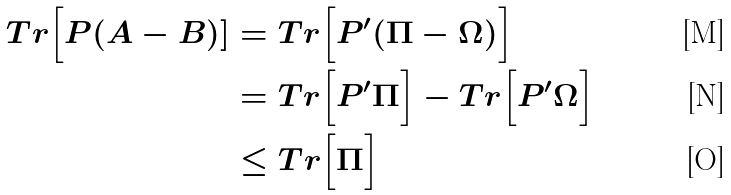<formula> <loc_0><loc_0><loc_500><loc_500>T r \Big [ P ( A - B ) ] & = T r \Big [ P ^ { \prime } ( \Pi - \Omega ) \Big ] \\ & = T r \Big [ P ^ { \prime } \Pi \Big ] - T r \Big [ P ^ { \prime } \Omega \Big ] \\ & \leq T r \Big [ \Pi \Big ]</formula> 